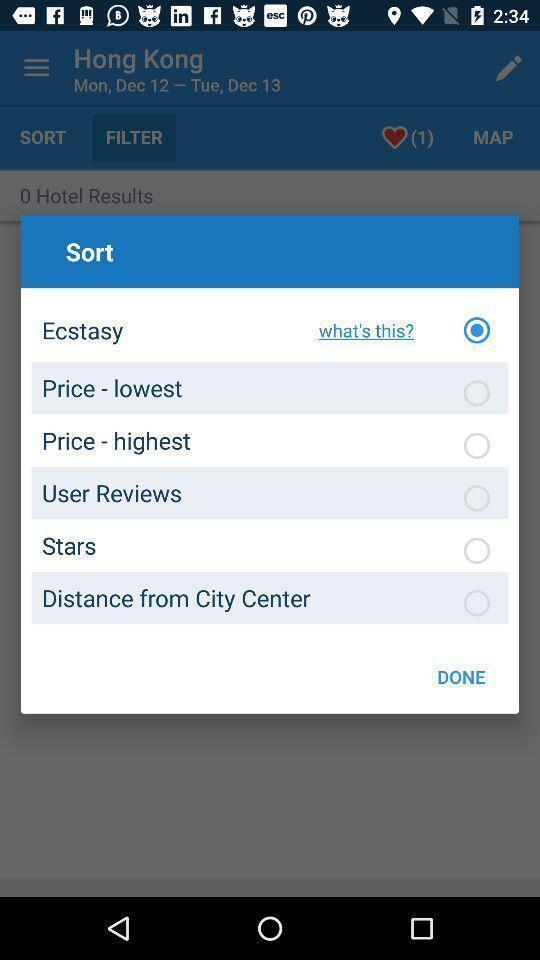Summarize the main components in this picture. Pop-up showing sort options for an app. 